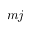<formula> <loc_0><loc_0><loc_500><loc_500>m j</formula> 